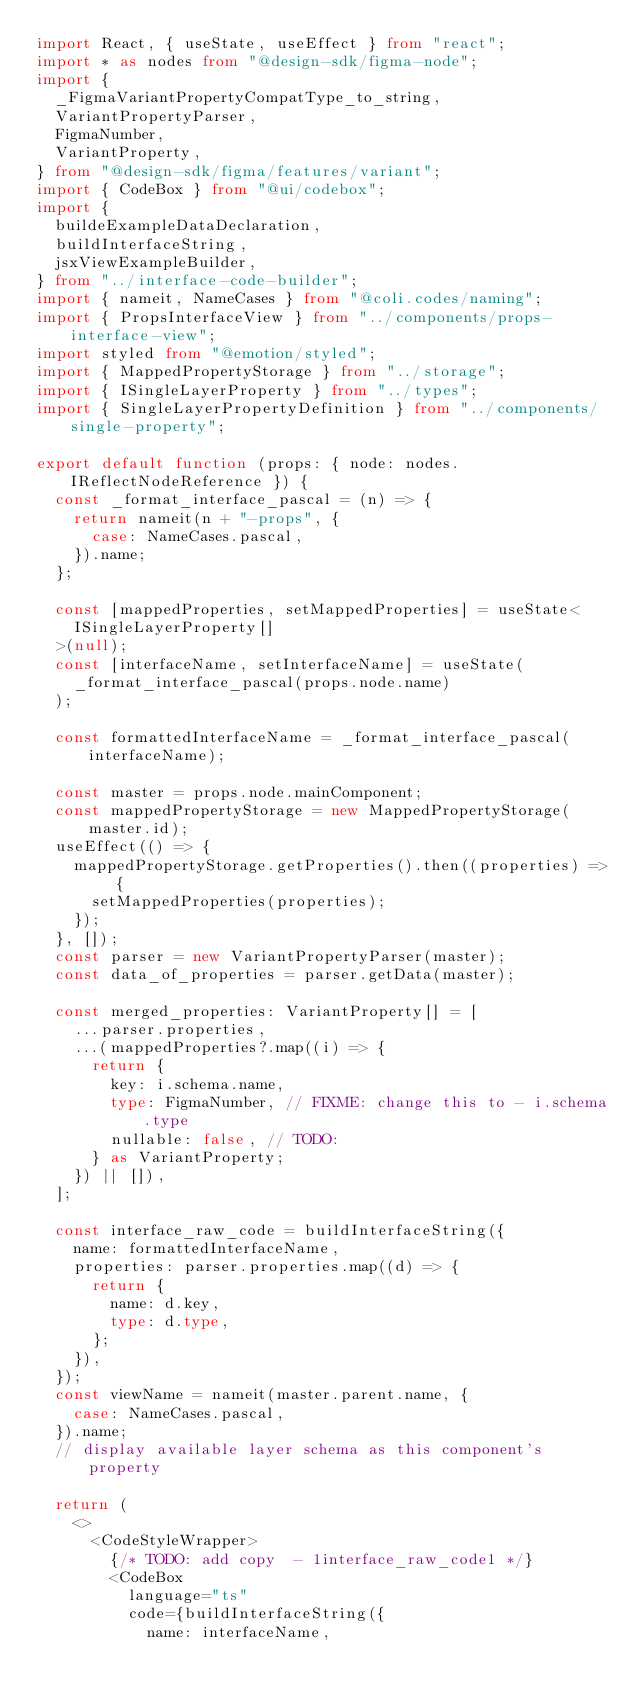<code> <loc_0><loc_0><loc_500><loc_500><_TypeScript_>import React, { useState, useEffect } from "react";
import * as nodes from "@design-sdk/figma-node";
import {
  _FigmaVariantPropertyCompatType_to_string,
  VariantPropertyParser,
  FigmaNumber,
  VariantProperty,
} from "@design-sdk/figma/features/variant";
import { CodeBox } from "@ui/codebox";
import {
  buildeExampleDataDeclaration,
  buildInterfaceString,
  jsxViewExampleBuilder,
} from "../interface-code-builder";
import { nameit, NameCases } from "@coli.codes/naming";
import { PropsInterfaceView } from "../components/props-interface-view";
import styled from "@emotion/styled";
import { MappedPropertyStorage } from "../storage";
import { ISingleLayerProperty } from "../types";
import { SingleLayerPropertyDefinition } from "../components/single-property";

export default function (props: { node: nodes.IReflectNodeReference }) {
  const _format_interface_pascal = (n) => {
    return nameit(n + "-props", {
      case: NameCases.pascal,
    }).name;
  };

  const [mappedProperties, setMappedProperties] = useState<
    ISingleLayerProperty[]
  >(null);
  const [interfaceName, setInterfaceName] = useState(
    _format_interface_pascal(props.node.name)
  );

  const formattedInterfaceName = _format_interface_pascal(interfaceName);

  const master = props.node.mainComponent;
  const mappedPropertyStorage = new MappedPropertyStorage(master.id);
  useEffect(() => {
    mappedPropertyStorage.getProperties().then((properties) => {
      setMappedProperties(properties);
    });
  }, []);
  const parser = new VariantPropertyParser(master);
  const data_of_properties = parser.getData(master);

  const merged_properties: VariantProperty[] = [
    ...parser.properties,
    ...(mappedProperties?.map((i) => {
      return {
        key: i.schema.name,
        type: FigmaNumber, // FIXME: change this to - i.schema.type
        nullable: false, // TODO:
      } as VariantProperty;
    }) || []),
  ];

  const interface_raw_code = buildInterfaceString({
    name: formattedInterfaceName,
    properties: parser.properties.map((d) => {
      return {
        name: d.key,
        type: d.type,
      };
    }),
  });
  const viewName = nameit(master.parent.name, {
    case: NameCases.pascal,
  }).name;
  // display available layer schema as this component's property

  return (
    <>
      <CodeStyleWrapper>
        {/* TODO: add copy  - 1interface_raw_code1 */}
        <CodeBox
          language="ts"
          code={buildInterfaceString({
            name: interfaceName,</code> 